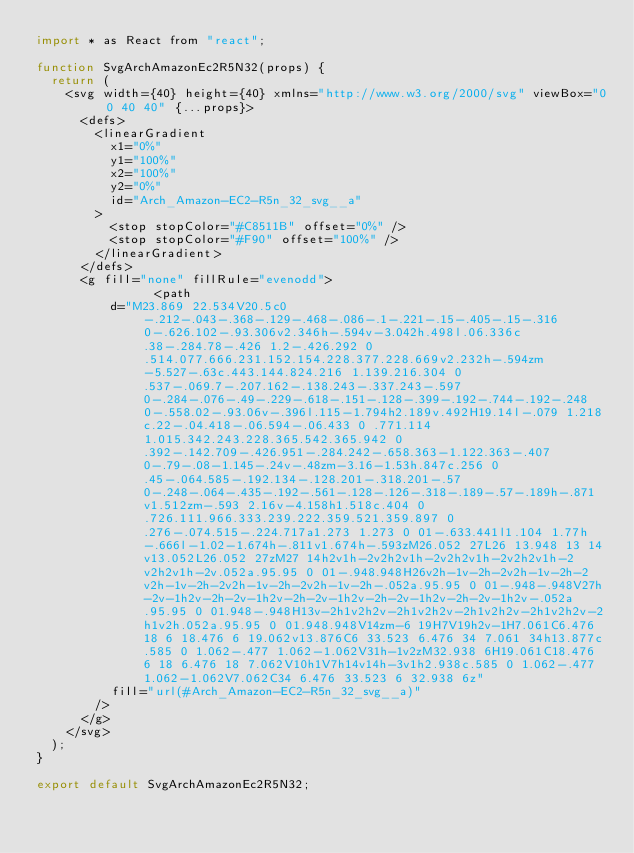<code> <loc_0><loc_0><loc_500><loc_500><_JavaScript_>import * as React from "react";

function SvgArchAmazonEc2R5N32(props) {
	return (
		<svg width={40} height={40} xmlns="http://www.w3.org/2000/svg" viewBox="0 0 40 40" {...props}>
			<defs>
				<linearGradient
					x1="0%"
					y1="100%"
					x2="100%"
					y2="0%"
					id="Arch_Amazon-EC2-R5n_32_svg__a"
				>
					<stop stopColor="#C8511B" offset="0%" />
					<stop stopColor="#F90" offset="100%" />
				</linearGradient>
			</defs>
			<g fill="none" fillRule="evenodd">
								<path
					d="M23.869 22.534V20.5c0-.212-.043-.368-.129-.468-.086-.1-.221-.15-.405-.15-.316 0-.626.102-.93.306v2.346h-.594v-3.042h.498l.06.336c.38-.284.78-.426 1.2-.426.292 0 .514.077.666.231.152.154.228.377.228.669v2.232h-.594zm-5.527-.63c.443.144.824.216 1.139.216.304 0 .537-.069.7-.207.162-.138.243-.337.243-.597 0-.284-.076-.49-.229-.618-.151-.128-.399-.192-.744-.192-.248 0-.558.02-.93.06v-.396l.115-1.794h2.189v.492H19.14l-.079 1.218c.22-.04.418-.06.594-.06.433 0 .771.114 1.015.342.243.228.365.542.365.942 0 .392-.142.709-.426.951-.284.242-.658.363-1.122.363-.407 0-.79-.08-1.145-.24v-.48zm-3.16-1.53h.847c.256 0 .45-.064.585-.192.134-.128.201-.318.201-.57 0-.248-.064-.435-.192-.561-.128-.126-.318-.189-.57-.189h-.871v1.512zm-.593 2.16v-4.158h1.518c.404 0 .726.111.966.333.239.222.359.521.359.897 0 .276-.074.515-.224.717a1.273 1.273 0 01-.633.441l1.104 1.77h-.666l-1.02-1.674h-.811v1.674h-.593zM26.052 27L26 13.948 13 14v13.052L26.052 27zM27 14h2v1h-2v2h2v1h-2v2h2v1h-2v2h2v1h-2v2h2v1h-2v.052a.95.95 0 01-.948.948H26v2h-1v-2h-2v2h-1v-2h-2v2h-1v-2h-2v2h-1v-2h-2v2h-1v-2h-.052a.95.95 0 01-.948-.948V27h-2v-1h2v-2h-2v-1h2v-2h-2v-1h2v-2h-2v-1h2v-2h-2v-1h2v-.052a.95.95 0 01.948-.948H13v-2h1v2h2v-2h1v2h2v-2h1v2h2v-2h1v2h2v-2h1v2h.052a.95.95 0 01.948.948V14zm-6 19H7V19h2v-1H7.061C6.476 18 6 18.476 6 19.062v13.876C6 33.523 6.476 34 7.061 34h13.877c.585 0 1.062-.477 1.062-1.062V31h-1v2zM32.938 6H19.061C18.476 6 18 6.476 18 7.062V10h1V7h14v14h-3v1h2.938c.585 0 1.062-.477 1.062-1.062V7.062C34 6.476 33.523 6 32.938 6z"
					fill="url(#Arch_Amazon-EC2-R5n_32_svg__a)"
				/>
			</g>
		</svg>
	);
}

export default SvgArchAmazonEc2R5N32;
</code> 